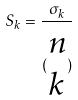Convert formula to latex. <formula><loc_0><loc_0><loc_500><loc_500>S _ { k } = \frac { \sigma _ { k } } { ( \begin{matrix} n \\ k \end{matrix} ) }</formula> 